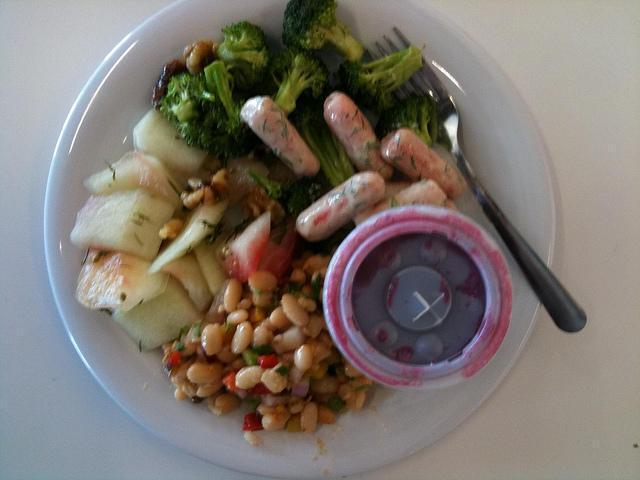How many bowls of food are there?
Give a very brief answer. 1. How many broccolis can be seen?
Give a very brief answer. 3. How many carrots can be seen?
Give a very brief answer. 4. How many ovens in this image have a window on their door?
Give a very brief answer. 0. 